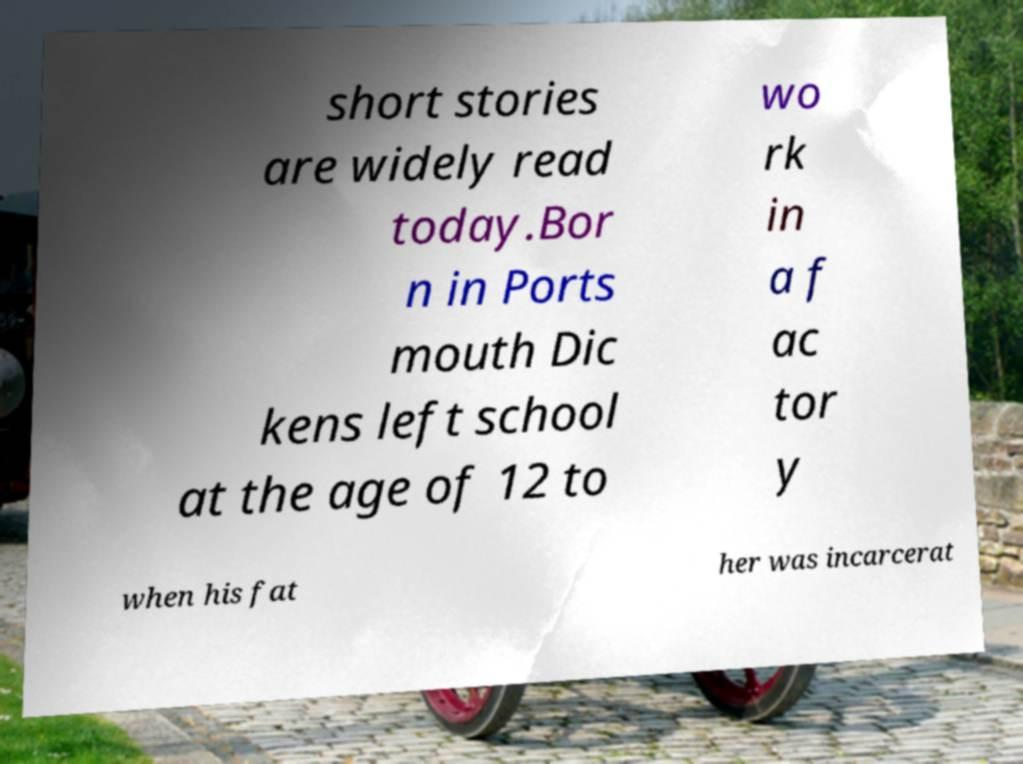I need the written content from this picture converted into text. Can you do that? short stories are widely read today.Bor n in Ports mouth Dic kens left school at the age of 12 to wo rk in a f ac tor y when his fat her was incarcerat 